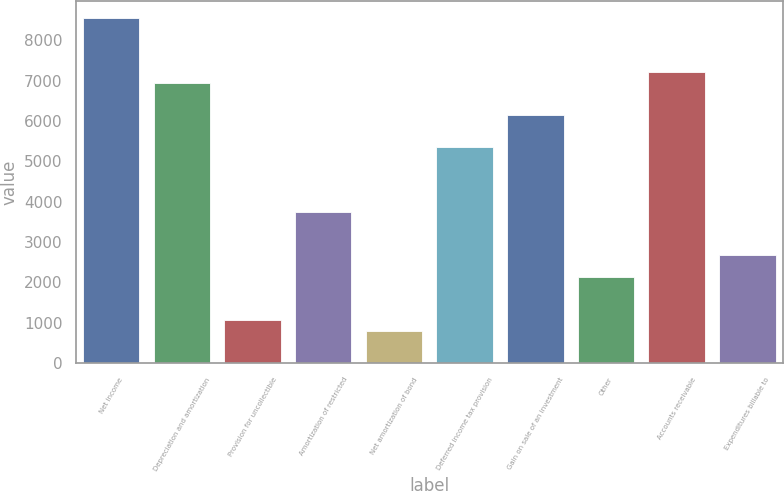Convert chart. <chart><loc_0><loc_0><loc_500><loc_500><bar_chart><fcel>Net income<fcel>Depreciation and amortization<fcel>Provision for uncollectible<fcel>Amortization of restricted<fcel>Net amortization of bond<fcel>Deferred income tax provision<fcel>Gain on sale of an investment<fcel>Other<fcel>Accounts receivable<fcel>Expenditures billable to<nl><fcel>8559.4<fcel>6954.76<fcel>1071.08<fcel>3745.48<fcel>803.64<fcel>5350.12<fcel>6152.44<fcel>2140.84<fcel>7222.2<fcel>2675.72<nl></chart> 